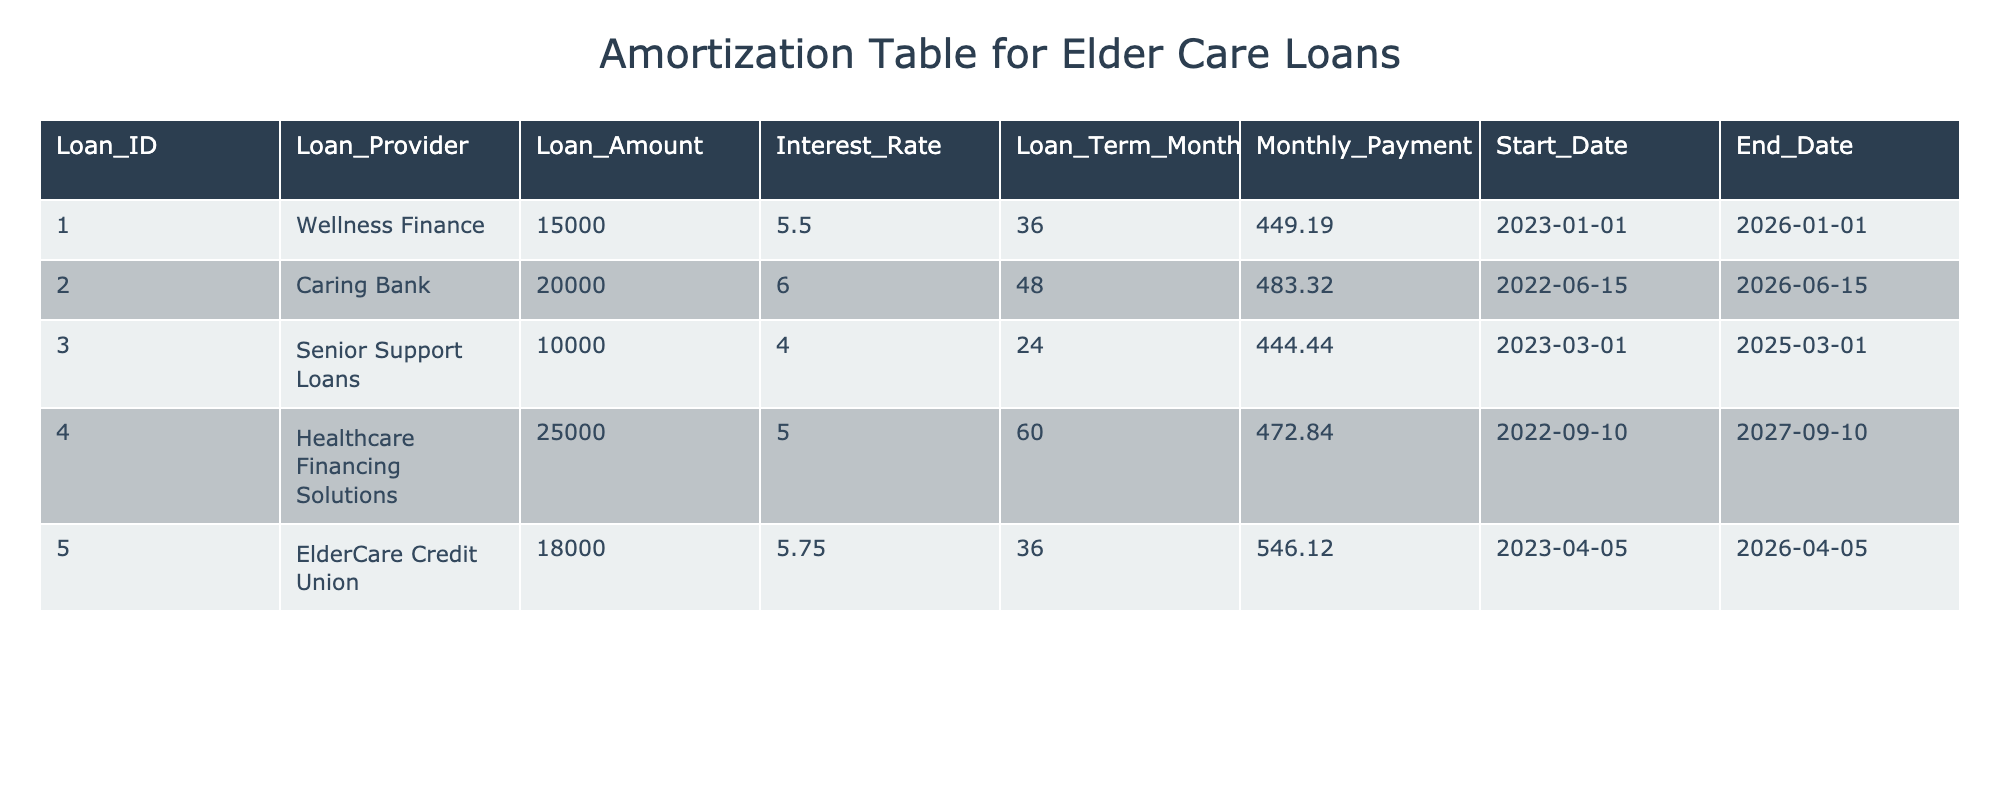What is the loan amount provided by Caring Bank? In the table, I can find the row for Caring Bank. The loan amount listed under "Loan_Amount" for Caring Bank is 20000.
Answer: 20000 What is the monthly payment for the loan taken from ElderCare Credit Union? I can locate the row corresponding to ElderCare Credit Union, and under "Monthly_Payment," the amount is listed as 546.12.
Answer: 546.12 Is the interest rate for the loan from Senior Support Loans higher than 4%? The interest rate for Senior Support Loans is listed as 4.0, which is not higher than 4%.
Answer: No What is the total amount of loans for all providers combined? To find the total, I sum the "Loan_Amount" for each provider: 15000 + 20000 + 10000 + 25000 + 18000 = 88000.
Answer: 88000 Which loan provider has the shortest loan term and how long is it? Looking at the loan terms in months, Senior Support Loans has a loan term of 24 months, which is the shortest compared to others.
Answer: Senior Support Loans, 24 months What is the average monthly payment for the loans listed in the table? I total the monthly payments: 449.19 + 483.32 + 444.44 + 472.84 + 546.12 = 2395.91, and then divide by 5 (the total number of loans) to find the average: 2395.91 / 5 = 479.182.
Answer: 479.18 Did Healthcare Financing Solutions offer a loan amount greater than the average loan amount in the table? First, I calculate the average loan amount which is 88000 / 5 = 17600. Healthcare Financing Solutions offered 25000, which is greater than 17600.
Answer: Yes Which loan provider has the highest interest rate and what is it? Upon reviewing the "Interest_Rate" column, I see that ElderCare Credit Union has the highest rate at 5.75%.
Answer: ElderCare Credit Union, 5.75% What is the total loan amount for loans with an interest rate of less than 5.5%? Filtering loans with an interest rate below 5.5%, only Senior Support Loans (10000) and Healthcare Financing Solutions (25000) qualify. The total calculated is 10000 + 25000 = 35000.
Answer: 35000 